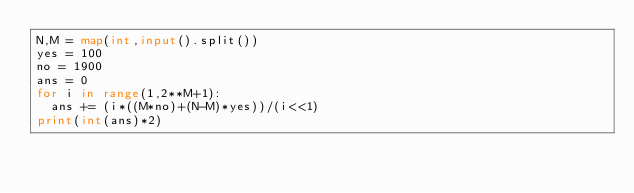<code> <loc_0><loc_0><loc_500><loc_500><_Python_>N,M = map(int,input().split())
yes = 100
no = 1900
ans = 0
for i in range(1,2**M+1):
  ans += (i*((M*no)+(N-M)*yes))/(i<<1)
print(int(ans)*2)</code> 